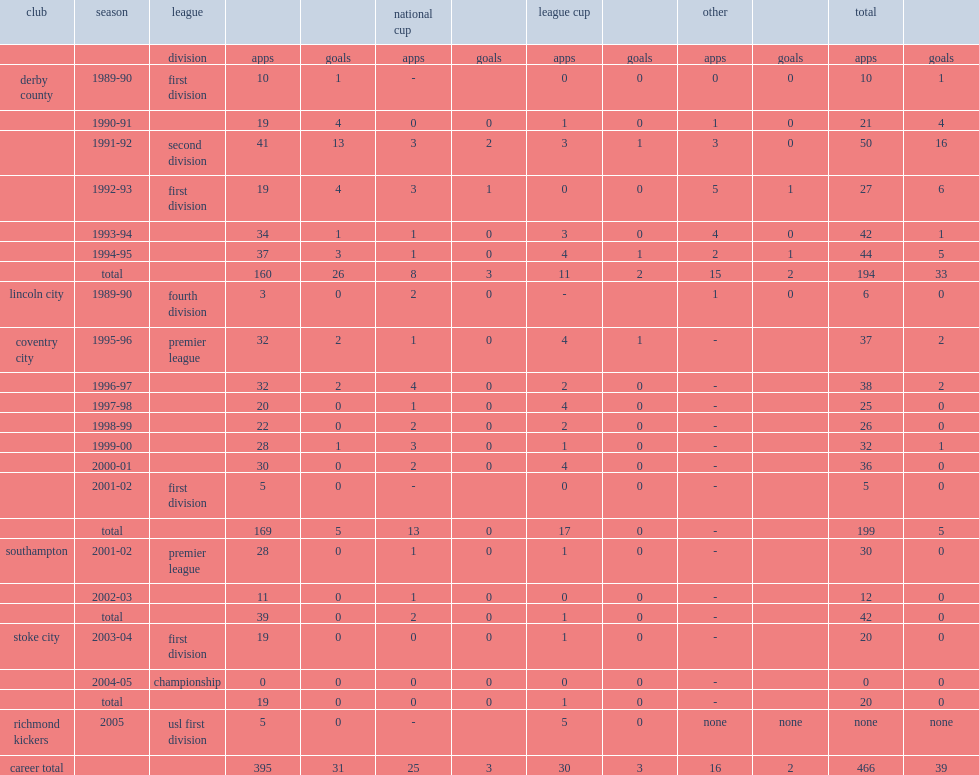Williams began his career with first division's club derby county during the 1989-90 season, how many appearances did he make for the club? 10.0. Williams began his career with first division's club derby county during the 1989-90 season, how many goals did he score for the club? 1.0. Could you help me parse every detail presented in this table? {'header': ['club', 'season', 'league', '', '', 'national cup', '', 'league cup', '', 'other', '', 'total', ''], 'rows': [['', '', 'division', 'apps', 'goals', 'apps', 'goals', 'apps', 'goals', 'apps', 'goals', 'apps', 'goals'], ['derby county', '1989-90', 'first division', '10', '1', '-', '', '0', '0', '0', '0', '10', '1'], ['', '1990-91', '', '19', '4', '0', '0', '1', '0', '1', '0', '21', '4'], ['', '1991-92', 'second division', '41', '13', '3', '2', '3', '1', '3', '0', '50', '16'], ['', '1992-93', 'first division', '19', '4', '3', '1', '0', '0', '5', '1', '27', '6'], ['', '1993-94', '', '34', '1', '1', '0', '3', '0', '4', '0', '42', '1'], ['', '1994-95', '', '37', '3', '1', '0', '4', '1', '2', '1', '44', '5'], ['', 'total', '', '160', '26', '8', '3', '11', '2', '15', '2', '194', '33'], ['lincoln city', '1989-90', 'fourth division', '3', '0', '2', '0', '-', '', '1', '0', '6', '0'], ['coventry city', '1995-96', 'premier league', '32', '2', '1', '0', '4', '1', '-', '', '37', '2'], ['', '1996-97', '', '32', '2', '4', '0', '2', '0', '-', '', '38', '2'], ['', '1997-98', '', '20', '0', '1', '0', '4', '0', '-', '', '25', '0'], ['', '1998-99', '', '22', '0', '2', '0', '2', '0', '-', '', '26', '0'], ['', '1999-00', '', '28', '1', '3', '0', '1', '0', '-', '', '32', '1'], ['', '2000-01', '', '30', '0', '2', '0', '4', '0', '-', '', '36', '0'], ['', '2001-02', 'first division', '5', '0', '-', '', '0', '0', '-', '', '5', '0'], ['', 'total', '', '169', '5', '13', '0', '17', '0', '-', '', '199', '5'], ['southampton', '2001-02', 'premier league', '28', '0', '1', '0', '1', '0', '-', '', '30', '0'], ['', '2002-03', '', '11', '0', '1', '0', '0', '0', '-', '', '12', '0'], ['', 'total', '', '39', '0', '2', '0', '1', '0', '-', '', '42', '0'], ['stoke city', '2003-04', 'first division', '19', '0', '0', '0', '1', '0', '-', '', '20', '0'], ['', '2004-05', 'championship', '0', '0', '0', '0', '0', '0', '-', '', '0', '0'], ['', 'total', '', '19', '0', '0', '0', '1', '0', '-', '', '20', '0'], ['richmond kickers', '2005', 'usl first division', '5', '0', '-', '', '5', '0', 'none', 'none', 'none', 'none'], ['career total', '', '', '395', '31', '25', '3', '30', '3', '16', '2', '466', '39']]} 